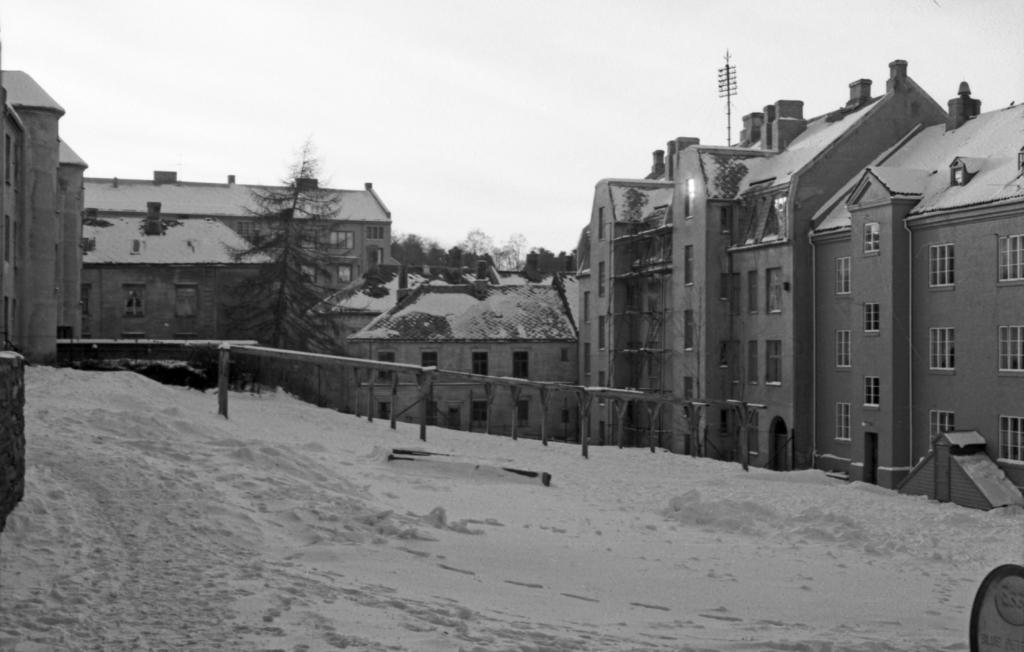What can be seen in the background of the image? There are buildings and trees in the background of the image. What is the condition of the ground in the center of the image? There is snow on the ground in the center of the image. What type of reward is hidden in the hole in the image? There is no hole or reward present in the image. What type of skin condition can be seen on the trees in the image? There is no mention of any skin condition on the trees in the image; they appear to be healthy. 